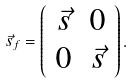Convert formula to latex. <formula><loc_0><loc_0><loc_500><loc_500>\vec { s } _ { f } = \left ( \begin{array} { c c } \vec { s } & 0 \\ 0 & \vec { s } \end{array} \right ) .</formula> 